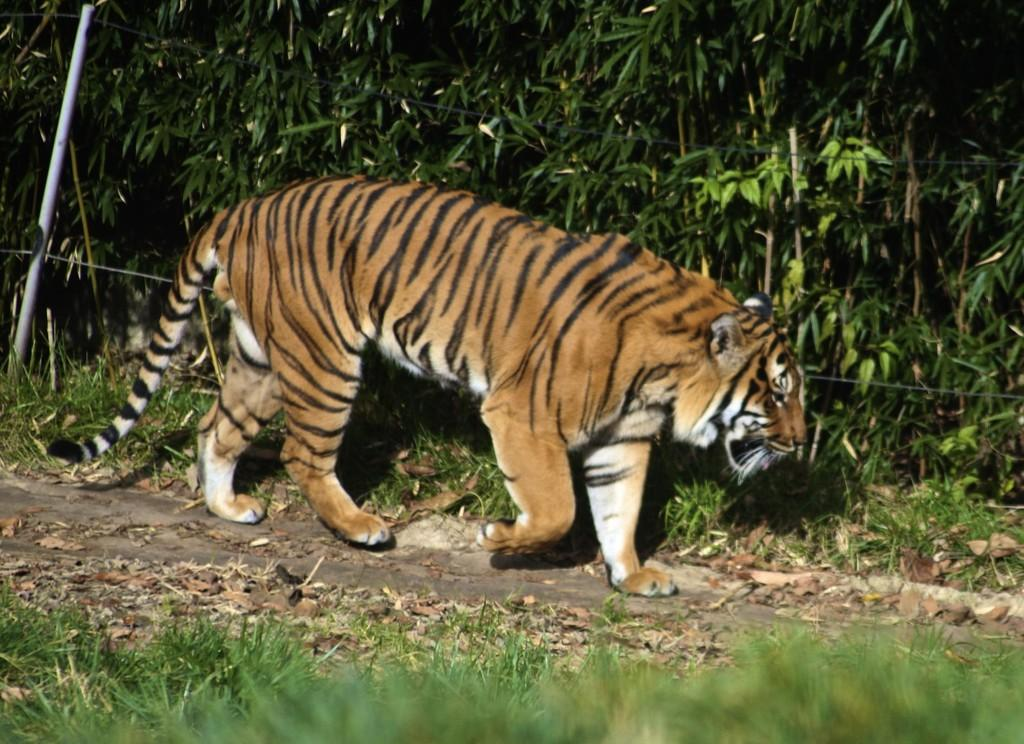What type of animal is in the image? There is a tiger in the image. What part of the tiger can be seen in the image? The tiger's tail is visible in the image. What type of vegetation is present in the image? There are trees and grass in the image. What else can be found on the ground in the image? Dried twigs are present on the ground in the image. Where is the faucet located in the image? There is no faucet present in the image. What type of soup is being served in the image? There is no soup present in the image. 